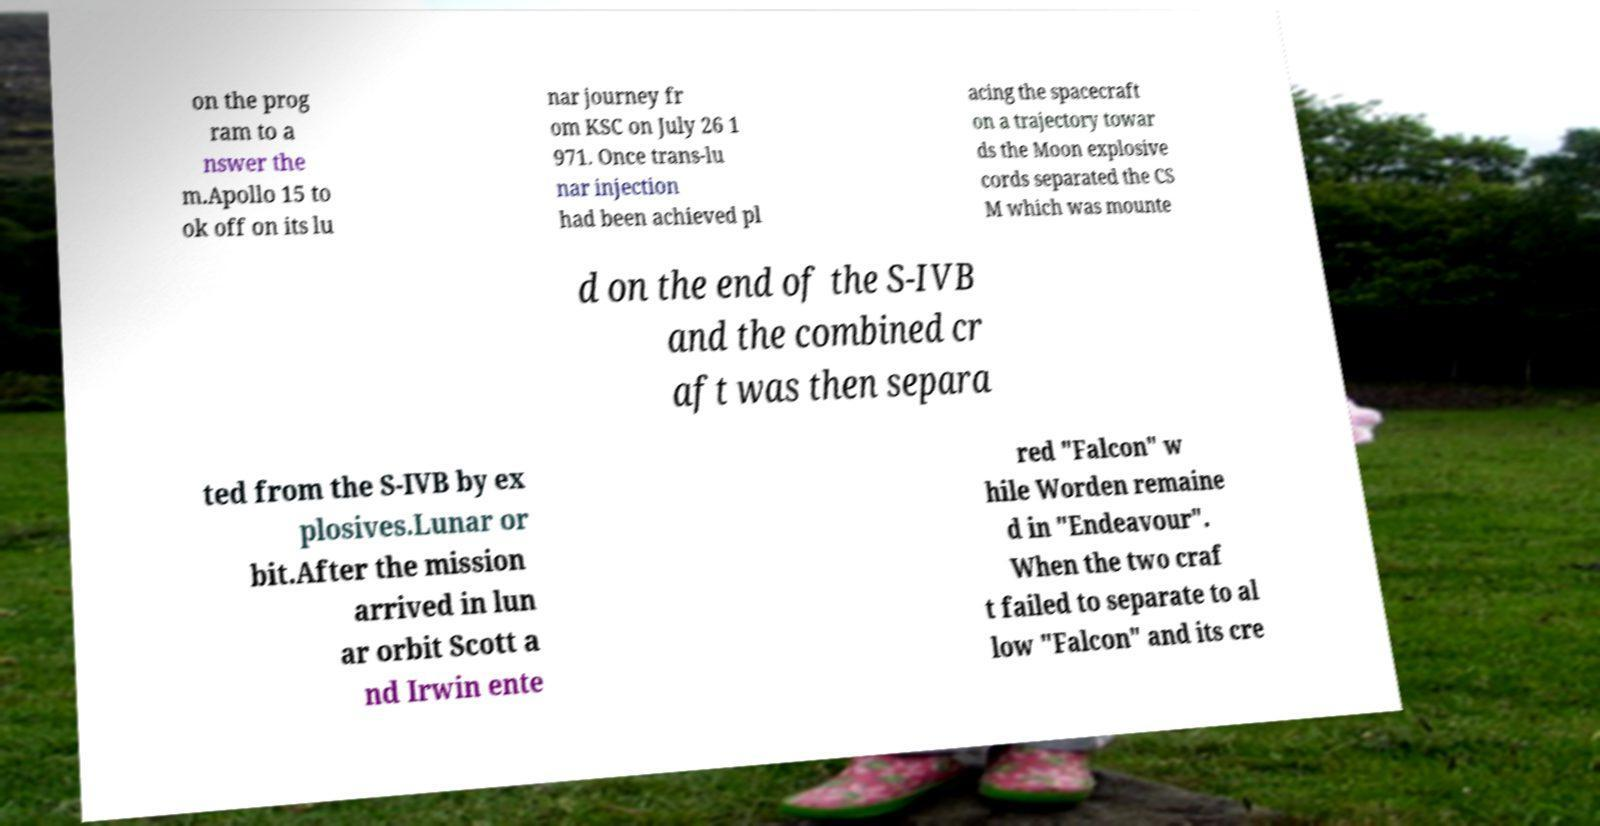Can you read and provide the text displayed in the image?This photo seems to have some interesting text. Can you extract and type it out for me? on the prog ram to a nswer the m.Apollo 15 to ok off on its lu nar journey fr om KSC on July 26 1 971. Once trans-lu nar injection had been achieved pl acing the spacecraft on a trajectory towar ds the Moon explosive cords separated the CS M which was mounte d on the end of the S-IVB and the combined cr aft was then separa ted from the S-IVB by ex plosives.Lunar or bit.After the mission arrived in lun ar orbit Scott a nd Irwin ente red "Falcon" w hile Worden remaine d in "Endeavour". When the two craf t failed to separate to al low "Falcon" and its cre 